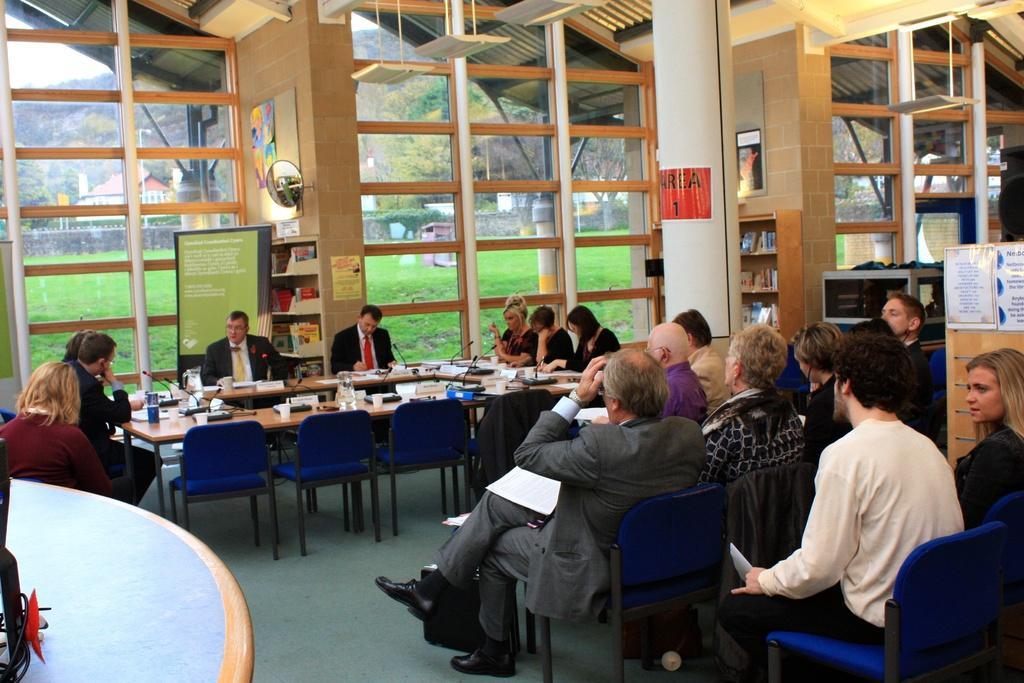Please provide a concise description of this image. In this image there are few people sitting on the chair at the right side of the image and few people are sitting before a table. having cup, microphones on it. At the left side there is a table. There are two racks in the room having books in it and at the background of the image there is a window from which grassy land, houses and some trees and sky are visible. 